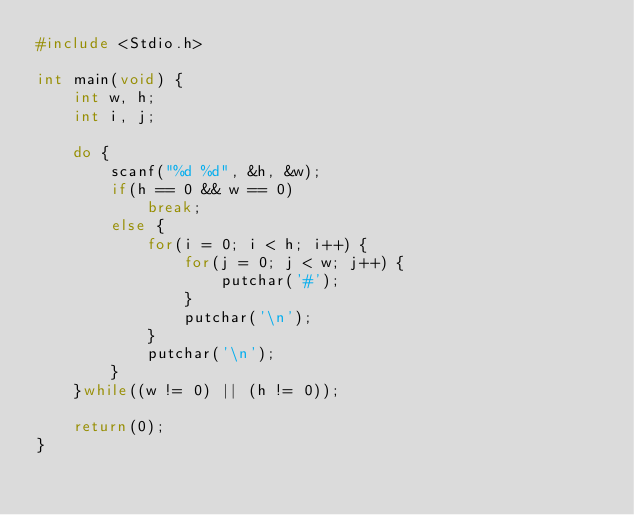<code> <loc_0><loc_0><loc_500><loc_500><_C_>#include <Stdio.h>

int main(void) {
    int w, h;
    int i, j;
    
    do {
        scanf("%d %d", &h, &w);
        if(h == 0 && w == 0)
            break;
        else {
            for(i = 0; i < h; i++) {
                for(j = 0; j < w; j++) {
                    putchar('#');
                }
                putchar('\n');
            }
            putchar('\n');
        }
    }while((w != 0) || (h != 0));
    
    return(0);
}</code> 